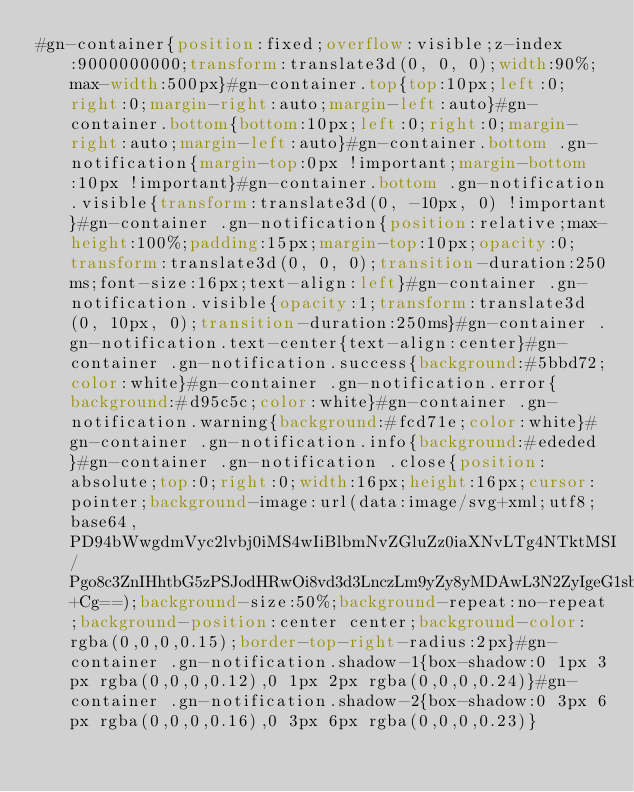<code> <loc_0><loc_0><loc_500><loc_500><_CSS_>#gn-container{position:fixed;overflow:visible;z-index:9000000000;transform:translate3d(0, 0, 0);width:90%;max-width:500px}#gn-container.top{top:10px;left:0;right:0;margin-right:auto;margin-left:auto}#gn-container.bottom{bottom:10px;left:0;right:0;margin-right:auto;margin-left:auto}#gn-container.bottom .gn-notification{margin-top:0px !important;margin-bottom:10px !important}#gn-container.bottom .gn-notification.visible{transform:translate3d(0, -10px, 0) !important}#gn-container .gn-notification{position:relative;max-height:100%;padding:15px;margin-top:10px;opacity:0;transform:translate3d(0, 0, 0);transition-duration:250ms;font-size:16px;text-align:left}#gn-container .gn-notification.visible{opacity:1;transform:translate3d(0, 10px, 0);transition-duration:250ms}#gn-container .gn-notification.text-center{text-align:center}#gn-container .gn-notification.success{background:#5bbd72;color:white}#gn-container .gn-notification.error{background:#d95c5c;color:white}#gn-container .gn-notification.warning{background:#fcd71e;color:white}#gn-container .gn-notification.info{background:#ededed}#gn-container .gn-notification .close{position:absolute;top:0;right:0;width:16px;height:16px;cursor:pointer;background-image:url(data:image/svg+xml;utf8;base64,PD94bWwgdmVyc2lvbj0iMS4wIiBlbmNvZGluZz0iaXNvLTg4NTktMSI/Pgo8c3ZnIHhtbG5zPSJodHRwOi8vd3d3LnczLm9yZy8yMDAwL3N2ZyIgeG1sbnM6eGxpbms9Imh0dHA6Ly93d3cudzMub3JnLzE5OTkveGxpbmsiIHZlcnNpb249IjEuMSIgdmlld0JveD0iMCAwIDIxLjkgMjEuOSIgZW5hYmxlLWJhY2tncm91bmQ9Im5ldyAwIDAgMjEuOSAyMS45IiB3aWR0aD0iMTZweCIgaGVpZ2h0PSIxNnB4Ij4KICA8cGF0aCBkPSJNMTQuMSwxMS4zYy0wLjItMC4yLTAuMi0wLjUsMC0wLjdsNy41LTcuNWMwLjItMC4yLDAuMy0wLjUsMC4zLTAuN3MtMC4xLTAuNS0wLjMtMC43bC0xLjQtMS40QzIwLDAuMSwxOS43LDAsMTkuNSwwICBjLTAuMywwLTAuNSwwLjEtMC43LDAuM2wtNy41LDcuNWMtMC4yLDAuMi0wLjUsMC4yLTAuNywwTDMuMSwwLjNDMi45LDAuMSwyLjYsMCwyLjQsMFMxLjksMC4xLDEuNywwLjNMMC4zLDEuN0MwLjEsMS45LDAsMi4yLDAsMi40ICBzMC4xLDAuNSwwLjMsMC43bDcuNSw3LjVjMC4yLDAuMiwwLjIsMC41LDAsMC43bC03LjUsNy41QzAuMSwxOSwwLDE5LjMsMCwxOS41czAuMSwwLjUsMC4zLDAuN2wxLjQsMS40YzAuMiwwLjIsMC41LDAuMywwLjcsMC4zICBzMC41LTAuMSwwLjctMC4zbDcuNS03LjVjMC4yLTAuMiwwLjUtMC4yLDAuNywwbDcuNSw3LjVjMC4yLDAuMiwwLjUsMC4zLDAuNywwLjNzMC41LTAuMSwwLjctMC4zbDEuNC0xLjRjMC4yLTAuMiwwLjMtMC41LDAuMy0wLjcgIHMtMC4xLTAuNS0wLjMtMC43TDE0LjEsMTEuM3oiIGZpbGw9IiNGRkZGRkYiLz4KPC9zdmc+Cg==);background-size:50%;background-repeat:no-repeat;background-position:center center;background-color:rgba(0,0,0,0.15);border-top-right-radius:2px}#gn-container .gn-notification.shadow-1{box-shadow:0 1px 3px rgba(0,0,0,0.12),0 1px 2px rgba(0,0,0,0.24)}#gn-container .gn-notification.shadow-2{box-shadow:0 3px 6px rgba(0,0,0,0.16),0 3px 6px rgba(0,0,0,0.23)}
</code> 